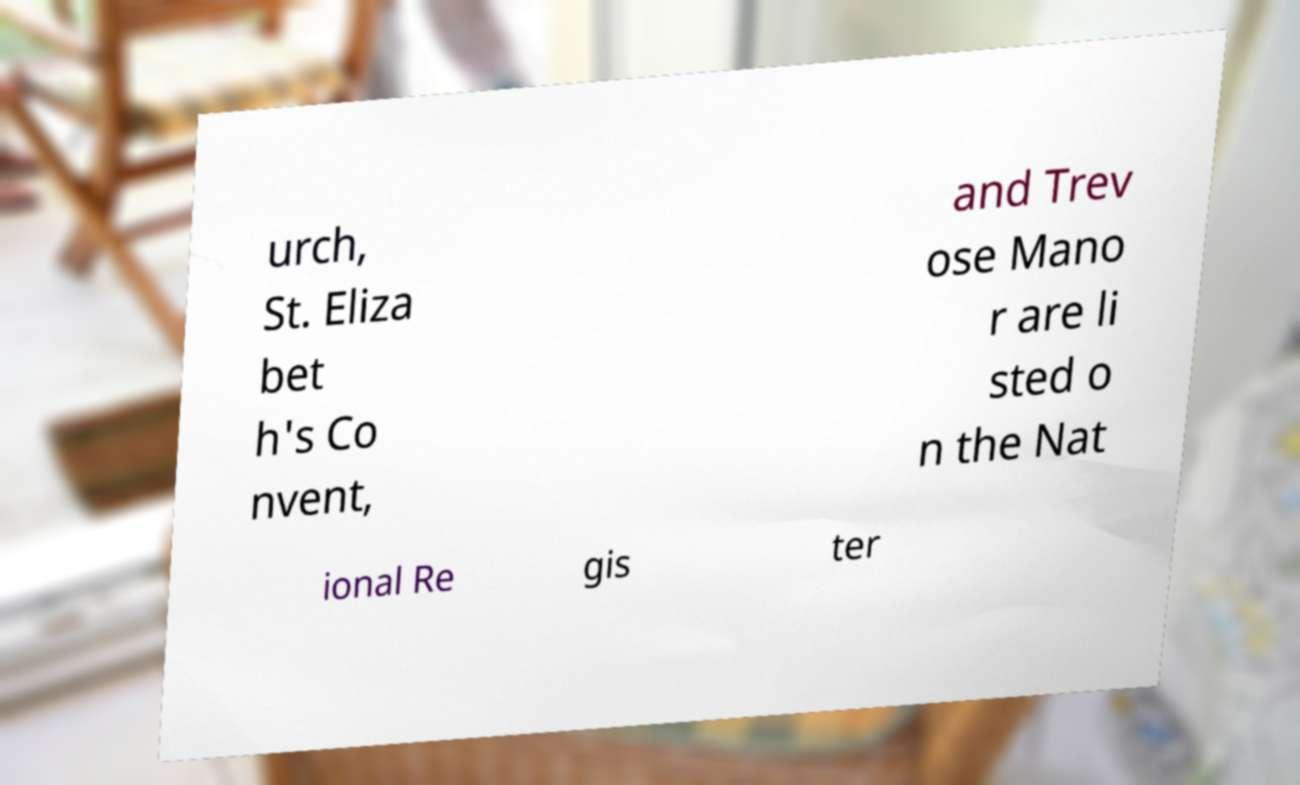I need the written content from this picture converted into text. Can you do that? urch, St. Eliza bet h's Co nvent, and Trev ose Mano r are li sted o n the Nat ional Re gis ter 